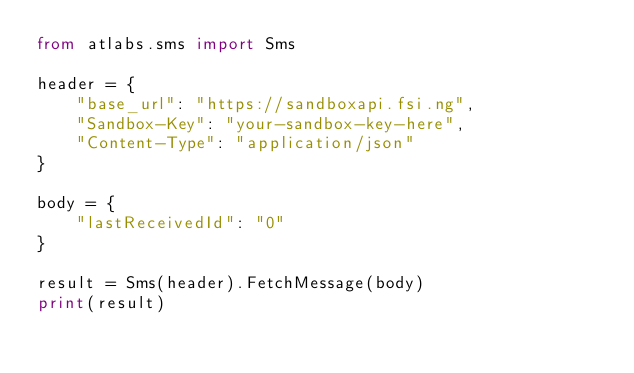Convert code to text. <code><loc_0><loc_0><loc_500><loc_500><_Python_>from atlabs.sms import Sms

header = {
    "base_url": "https://sandboxapi.fsi.ng",
    "Sandbox-Key": "your-sandbox-key-here",
    "Content-Type": "application/json"
}

body = {
    "lastReceivedId": "0"
}

result = Sms(header).FetchMessage(body)
print(result)
</code> 